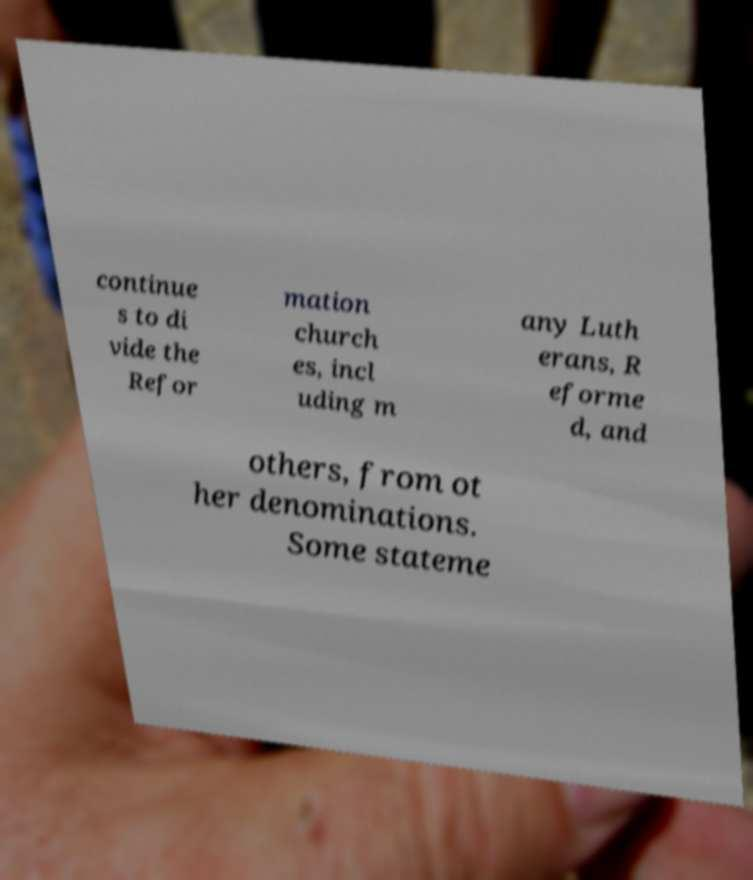Can you read and provide the text displayed in the image?This photo seems to have some interesting text. Can you extract and type it out for me? continue s to di vide the Refor mation church es, incl uding m any Luth erans, R eforme d, and others, from ot her denominations. Some stateme 